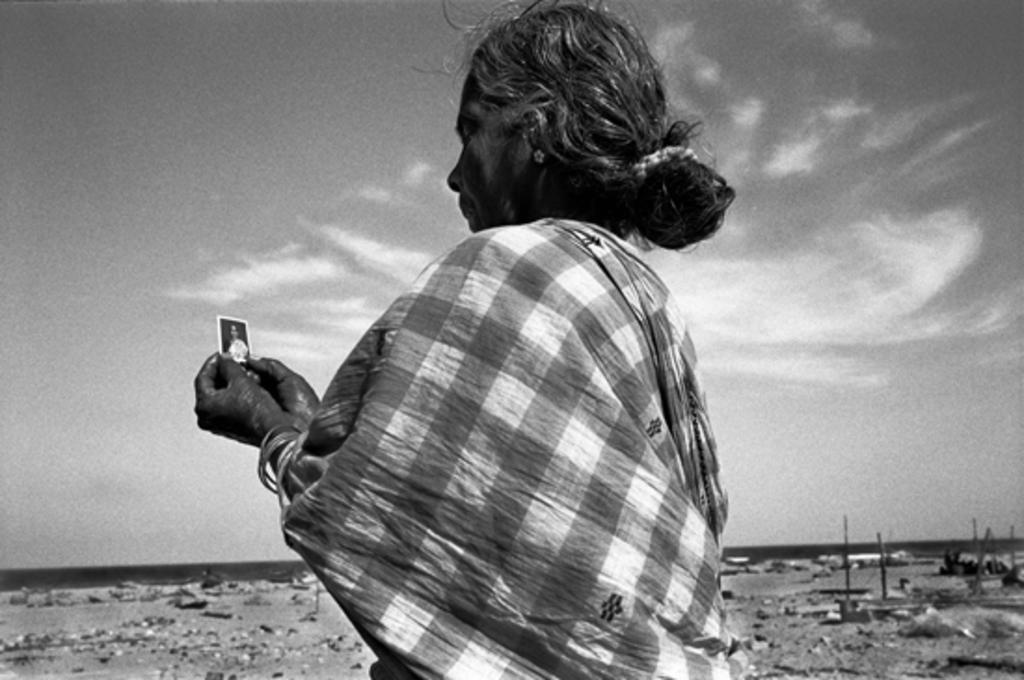Describe this image in one or two sentences. This is a black and white image we can see a lady wearing. In the background of the image there is sky and clouds. 